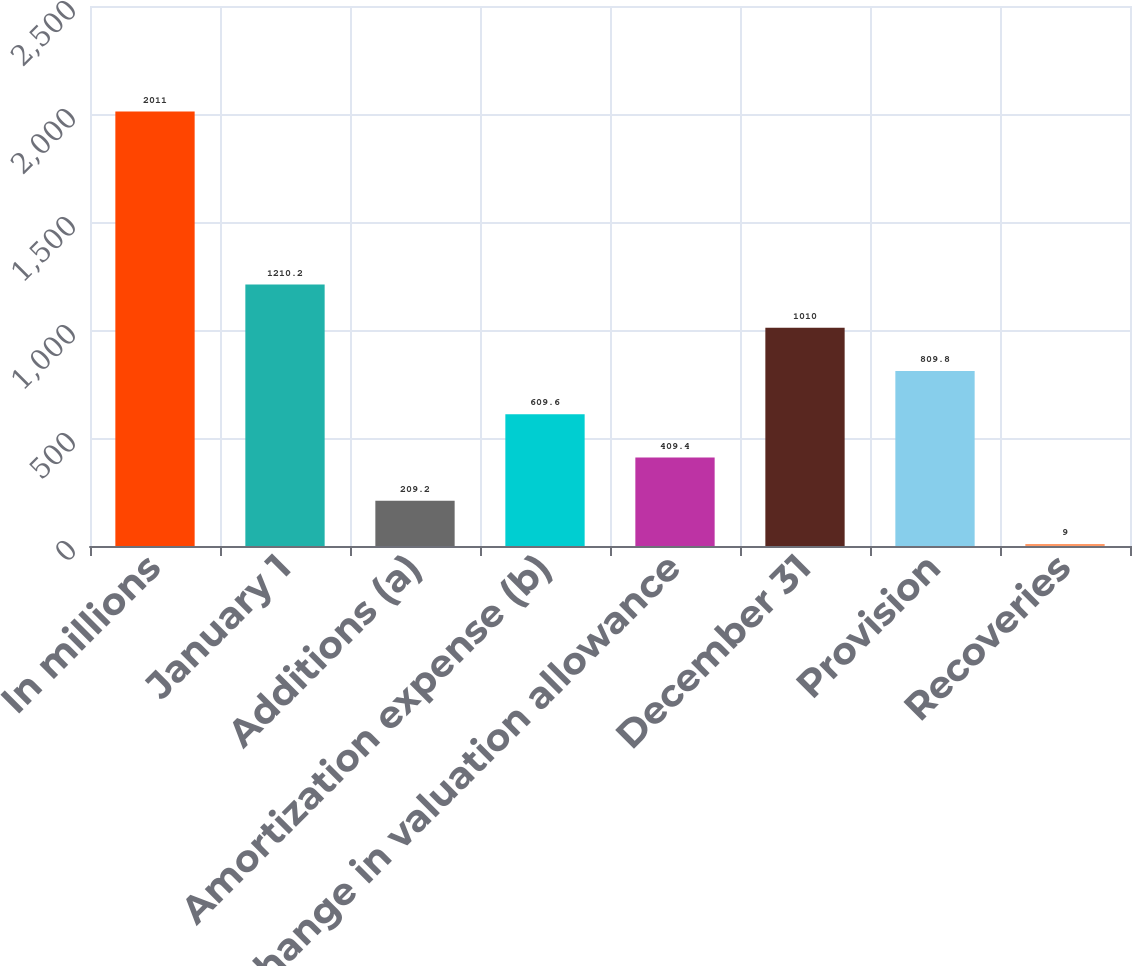Convert chart to OTSL. <chart><loc_0><loc_0><loc_500><loc_500><bar_chart><fcel>In millions<fcel>January 1<fcel>Additions (a)<fcel>Amortization expense (b)<fcel>Change in valuation allowance<fcel>December 31<fcel>Provision<fcel>Recoveries<nl><fcel>2011<fcel>1210.2<fcel>209.2<fcel>609.6<fcel>409.4<fcel>1010<fcel>809.8<fcel>9<nl></chart> 